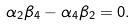Convert formula to latex. <formula><loc_0><loc_0><loc_500><loc_500>\alpha _ { 2 } \beta _ { 4 } - \alpha _ { 4 } \beta _ { 2 } = 0 .</formula> 